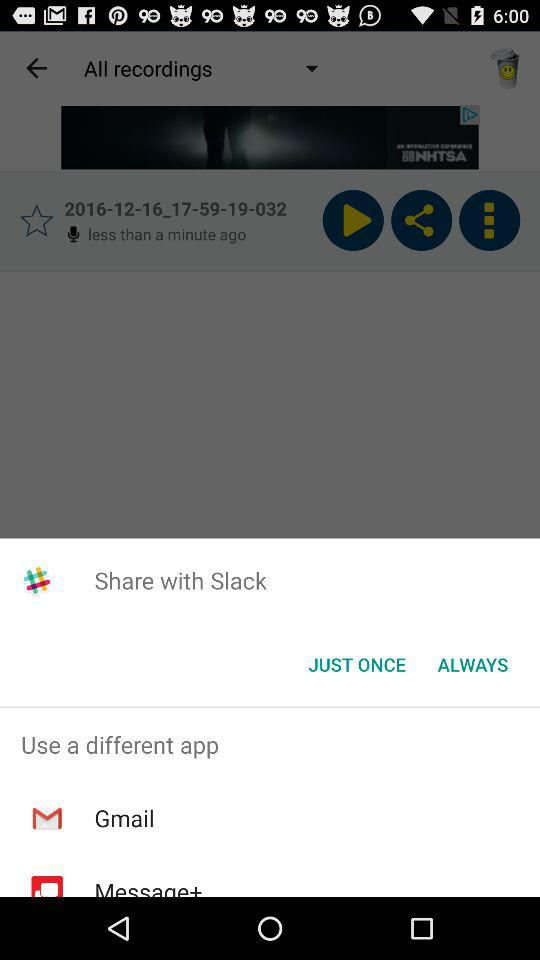Which applications I can use for sharing the content? You can share it with Slack. 